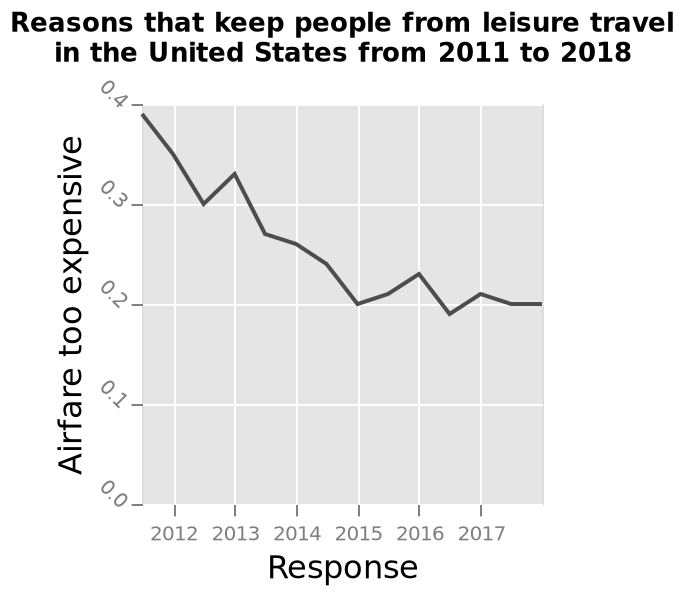<image>
What does the x-axis on the area graph represent? The x-axis represents the "Response" variable. Did the number of people finding airfare costs inhibiting decrease or increase?  The number of people finding airfare costs inhibiting decreased over time. What is the time period covered in the line diagram? The line diagram covers the time period from 2011 to 2018. Did the number of people finding airfare costs inhibiting increase over time? No. The number of people finding airfare costs inhibiting decreased over time. 